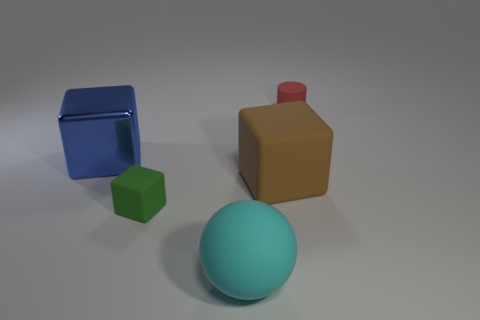Subtract 1 cubes. How many cubes are left? 2 Add 2 tiny gray blocks. How many objects exist? 7 Subtract all blocks. How many objects are left? 2 Add 4 tiny rubber objects. How many tiny rubber objects exist? 6 Subtract 0 green cylinders. How many objects are left? 5 Subtract all matte things. Subtract all cyan spheres. How many objects are left? 0 Add 1 big cyan matte spheres. How many big cyan matte spheres are left? 2 